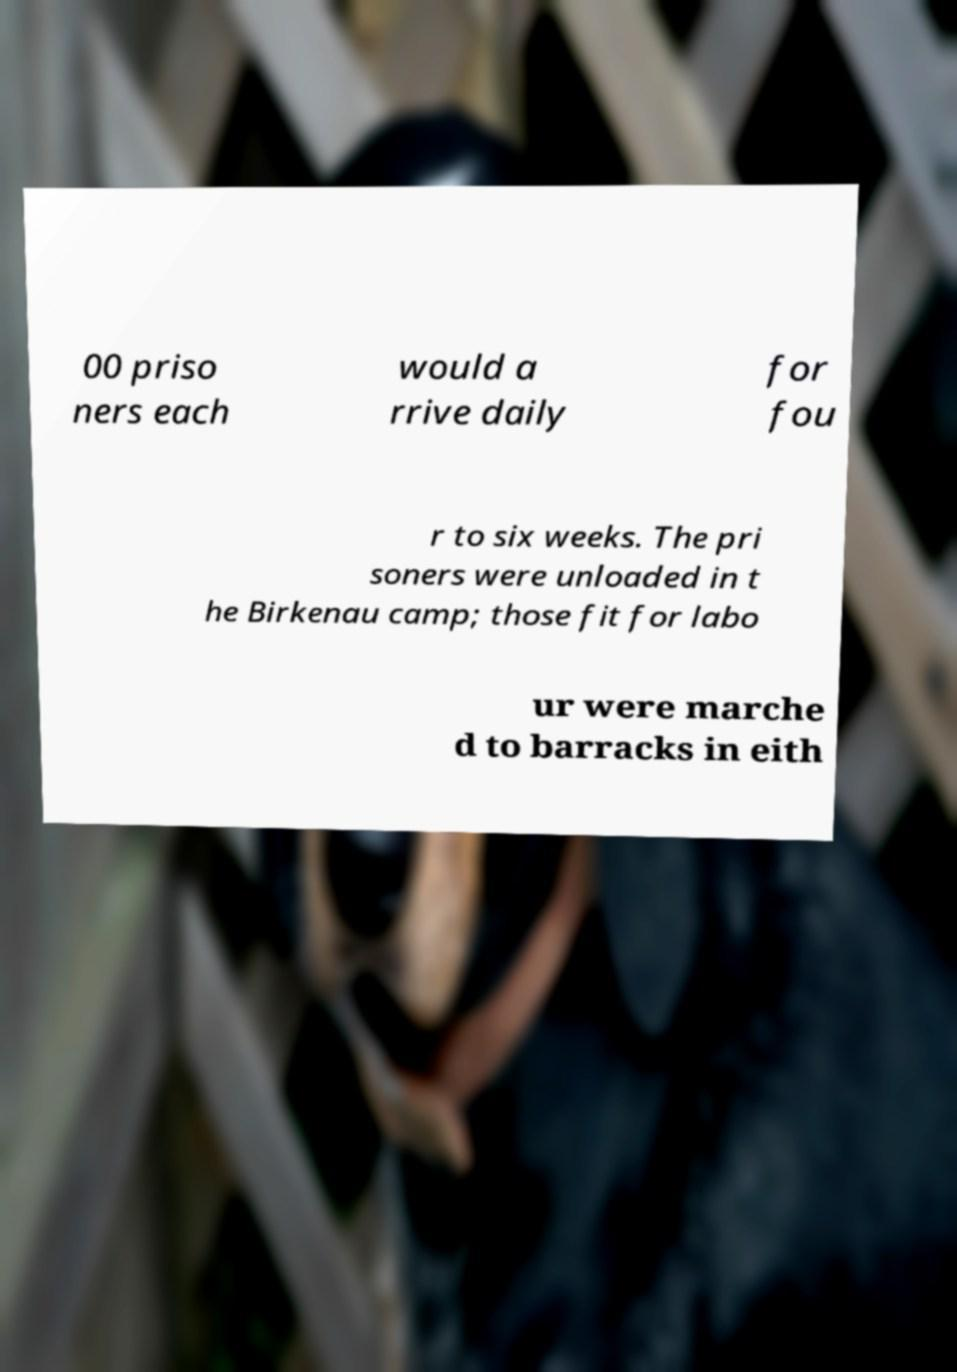Can you read and provide the text displayed in the image?This photo seems to have some interesting text. Can you extract and type it out for me? 00 priso ners each would a rrive daily for fou r to six weeks. The pri soners were unloaded in t he Birkenau camp; those fit for labo ur were marche d to barracks in eith 